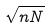Convert formula to latex. <formula><loc_0><loc_0><loc_500><loc_500>\sqrt { n N }</formula> 